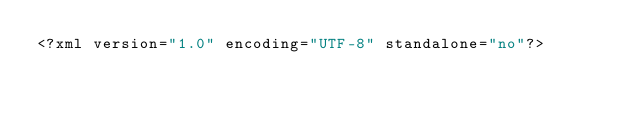Convert code to text. <code><loc_0><loc_0><loc_500><loc_500><_HTML_><?xml version="1.0" encoding="UTF-8" standalone="no"?></code> 